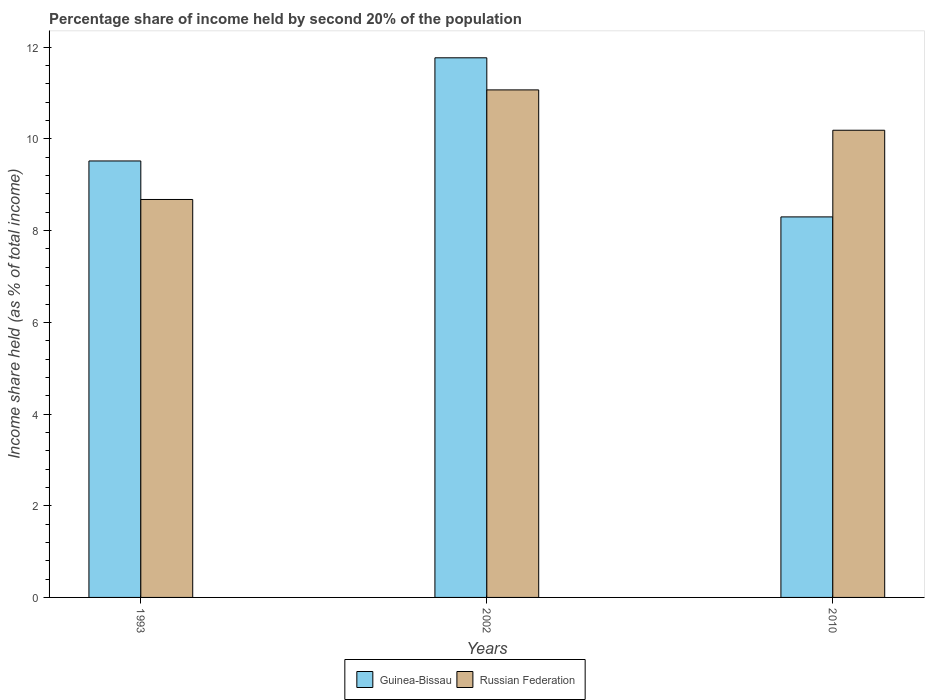How many different coloured bars are there?
Keep it short and to the point. 2. How many groups of bars are there?
Make the answer very short. 3. Are the number of bars per tick equal to the number of legend labels?
Your answer should be compact. Yes. How many bars are there on the 2nd tick from the right?
Your answer should be compact. 2. What is the label of the 1st group of bars from the left?
Make the answer very short. 1993. In how many cases, is the number of bars for a given year not equal to the number of legend labels?
Make the answer very short. 0. What is the share of income held by second 20% of the population in Russian Federation in 2010?
Make the answer very short. 10.19. Across all years, what is the maximum share of income held by second 20% of the population in Guinea-Bissau?
Your response must be concise. 11.77. In which year was the share of income held by second 20% of the population in Russian Federation maximum?
Your answer should be compact. 2002. In which year was the share of income held by second 20% of the population in Guinea-Bissau minimum?
Provide a short and direct response. 2010. What is the total share of income held by second 20% of the population in Guinea-Bissau in the graph?
Make the answer very short. 29.59. What is the difference between the share of income held by second 20% of the population in Russian Federation in 2002 and that in 2010?
Keep it short and to the point. 0.88. What is the difference between the share of income held by second 20% of the population in Guinea-Bissau in 2010 and the share of income held by second 20% of the population in Russian Federation in 2002?
Give a very brief answer. -2.77. What is the average share of income held by second 20% of the population in Guinea-Bissau per year?
Offer a very short reply. 9.86. In the year 2002, what is the difference between the share of income held by second 20% of the population in Russian Federation and share of income held by second 20% of the population in Guinea-Bissau?
Provide a succinct answer. -0.7. In how many years, is the share of income held by second 20% of the population in Russian Federation greater than 3.2 %?
Make the answer very short. 3. What is the ratio of the share of income held by second 20% of the population in Guinea-Bissau in 1993 to that in 2002?
Keep it short and to the point. 0.81. Is the share of income held by second 20% of the population in Guinea-Bissau in 1993 less than that in 2002?
Keep it short and to the point. Yes. Is the difference between the share of income held by second 20% of the population in Russian Federation in 1993 and 2002 greater than the difference between the share of income held by second 20% of the population in Guinea-Bissau in 1993 and 2002?
Your answer should be very brief. No. What is the difference between the highest and the second highest share of income held by second 20% of the population in Guinea-Bissau?
Your answer should be very brief. 2.25. What is the difference between the highest and the lowest share of income held by second 20% of the population in Russian Federation?
Offer a very short reply. 2.39. Is the sum of the share of income held by second 20% of the population in Guinea-Bissau in 2002 and 2010 greater than the maximum share of income held by second 20% of the population in Russian Federation across all years?
Provide a succinct answer. Yes. What does the 1st bar from the left in 2002 represents?
Provide a short and direct response. Guinea-Bissau. What does the 1st bar from the right in 1993 represents?
Make the answer very short. Russian Federation. Are all the bars in the graph horizontal?
Your answer should be compact. No. How many years are there in the graph?
Your response must be concise. 3. What is the difference between two consecutive major ticks on the Y-axis?
Make the answer very short. 2. Are the values on the major ticks of Y-axis written in scientific E-notation?
Your response must be concise. No. Does the graph contain grids?
Make the answer very short. No. How many legend labels are there?
Your answer should be very brief. 2. How are the legend labels stacked?
Provide a short and direct response. Horizontal. What is the title of the graph?
Ensure brevity in your answer.  Percentage share of income held by second 20% of the population. What is the label or title of the Y-axis?
Keep it short and to the point. Income share held (as % of total income). What is the Income share held (as % of total income) of Guinea-Bissau in 1993?
Your response must be concise. 9.52. What is the Income share held (as % of total income) of Russian Federation in 1993?
Your answer should be very brief. 8.68. What is the Income share held (as % of total income) in Guinea-Bissau in 2002?
Offer a very short reply. 11.77. What is the Income share held (as % of total income) in Russian Federation in 2002?
Give a very brief answer. 11.07. What is the Income share held (as % of total income) of Guinea-Bissau in 2010?
Offer a terse response. 8.3. What is the Income share held (as % of total income) in Russian Federation in 2010?
Offer a very short reply. 10.19. Across all years, what is the maximum Income share held (as % of total income) of Guinea-Bissau?
Your response must be concise. 11.77. Across all years, what is the maximum Income share held (as % of total income) of Russian Federation?
Give a very brief answer. 11.07. Across all years, what is the minimum Income share held (as % of total income) of Guinea-Bissau?
Make the answer very short. 8.3. Across all years, what is the minimum Income share held (as % of total income) of Russian Federation?
Provide a short and direct response. 8.68. What is the total Income share held (as % of total income) of Guinea-Bissau in the graph?
Your answer should be compact. 29.59. What is the total Income share held (as % of total income) of Russian Federation in the graph?
Offer a terse response. 29.94. What is the difference between the Income share held (as % of total income) of Guinea-Bissau in 1993 and that in 2002?
Your answer should be very brief. -2.25. What is the difference between the Income share held (as % of total income) in Russian Federation in 1993 and that in 2002?
Your answer should be compact. -2.39. What is the difference between the Income share held (as % of total income) in Guinea-Bissau in 1993 and that in 2010?
Your answer should be compact. 1.22. What is the difference between the Income share held (as % of total income) of Russian Federation in 1993 and that in 2010?
Your response must be concise. -1.51. What is the difference between the Income share held (as % of total income) of Guinea-Bissau in 2002 and that in 2010?
Ensure brevity in your answer.  3.47. What is the difference between the Income share held (as % of total income) of Russian Federation in 2002 and that in 2010?
Provide a short and direct response. 0.88. What is the difference between the Income share held (as % of total income) in Guinea-Bissau in 1993 and the Income share held (as % of total income) in Russian Federation in 2002?
Provide a short and direct response. -1.55. What is the difference between the Income share held (as % of total income) of Guinea-Bissau in 1993 and the Income share held (as % of total income) of Russian Federation in 2010?
Ensure brevity in your answer.  -0.67. What is the difference between the Income share held (as % of total income) of Guinea-Bissau in 2002 and the Income share held (as % of total income) of Russian Federation in 2010?
Your response must be concise. 1.58. What is the average Income share held (as % of total income) of Guinea-Bissau per year?
Offer a very short reply. 9.86. What is the average Income share held (as % of total income) of Russian Federation per year?
Provide a short and direct response. 9.98. In the year 1993, what is the difference between the Income share held (as % of total income) in Guinea-Bissau and Income share held (as % of total income) in Russian Federation?
Ensure brevity in your answer.  0.84. In the year 2010, what is the difference between the Income share held (as % of total income) in Guinea-Bissau and Income share held (as % of total income) in Russian Federation?
Your answer should be compact. -1.89. What is the ratio of the Income share held (as % of total income) of Guinea-Bissau in 1993 to that in 2002?
Provide a short and direct response. 0.81. What is the ratio of the Income share held (as % of total income) in Russian Federation in 1993 to that in 2002?
Make the answer very short. 0.78. What is the ratio of the Income share held (as % of total income) in Guinea-Bissau in 1993 to that in 2010?
Provide a succinct answer. 1.15. What is the ratio of the Income share held (as % of total income) in Russian Federation in 1993 to that in 2010?
Offer a terse response. 0.85. What is the ratio of the Income share held (as % of total income) in Guinea-Bissau in 2002 to that in 2010?
Offer a terse response. 1.42. What is the ratio of the Income share held (as % of total income) of Russian Federation in 2002 to that in 2010?
Your answer should be compact. 1.09. What is the difference between the highest and the second highest Income share held (as % of total income) in Guinea-Bissau?
Offer a very short reply. 2.25. What is the difference between the highest and the lowest Income share held (as % of total income) in Guinea-Bissau?
Ensure brevity in your answer.  3.47. What is the difference between the highest and the lowest Income share held (as % of total income) of Russian Federation?
Ensure brevity in your answer.  2.39. 